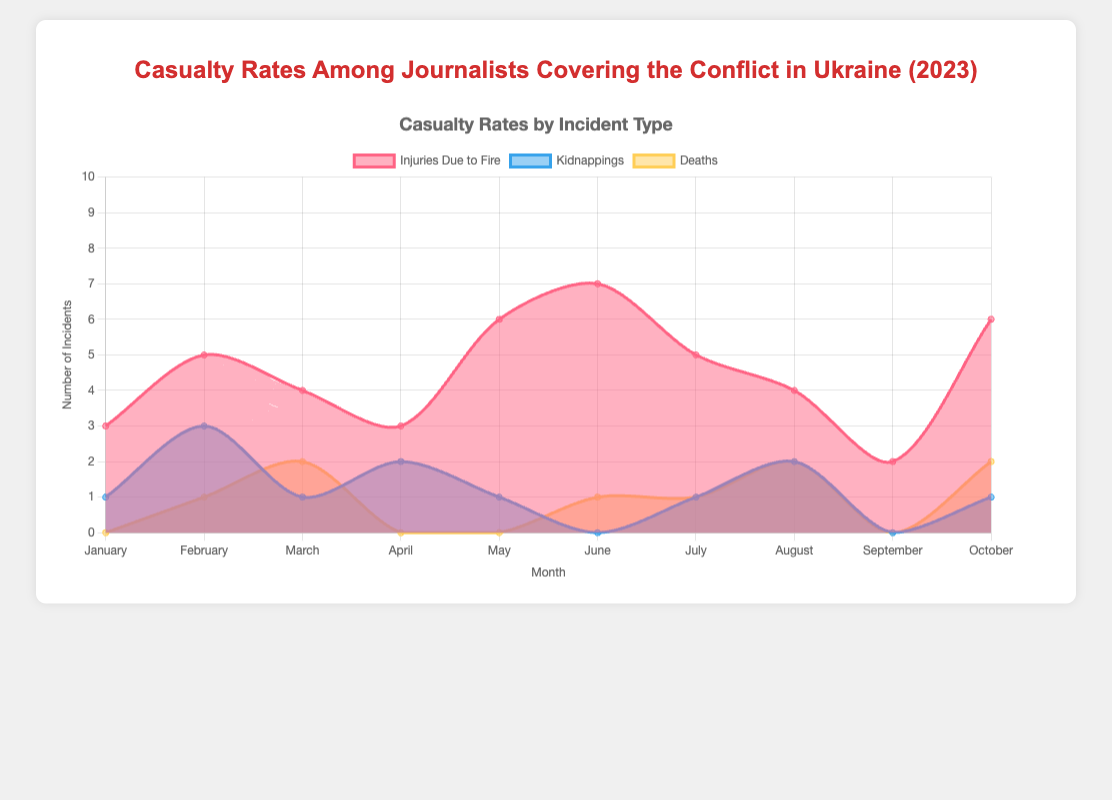How many injury incidents due to fire were reported in March 2023? Look at the "Injuries Due to Fire" area in the chart, and identify the value for the month of March.
Answer: 4 Which month had the highest number of journalist kidnappings? Find the peak value in the "Kidnappings" area and check the corresponding month.
Answer: February What was the total number of deaths among journalists reported in June and July 2023? Identify the values in the "Deaths" area for June and July, and sum them: 1 (June) + 1 (July).
Answer: 2 In which month were no injuries due to fire reported? Check each month's "Injuries Due to Fire" area and find the month with a value of 0.
Answer: None How does the number of injuries due to fire in January compare to that in May? Compare the values in the "Injuries Due to Fire" area for January (3) and May (6).
Answer: May had 3 more injuries In which month was the number of kidnappings equal to the number of deaths? Look for the months where the values of "Kidnappings" and "Deaths" are the same. Both are 2 in August.
Answer: August Calculate the average number of injuries due to fire over the first quarter of 2023 (January - March). Sum the values from January, February, and March in the "Injuries Due to Fire" area: 3 + 5 + 4 = 12. Divide by 3 months: 12/3.
Answer: 4 How many months reported more than 1 death? Count the months where the "Deaths" value is more than 1: three months (March, August, and October).
Answer: 3 What is the cumulative number of kidnapping incidents reported until June 2023? Sum the values in the "Kidnappings" area from January to June: 1 + 3 + 1 + 2 + 1 + 0 = 8.
Answer: 8 